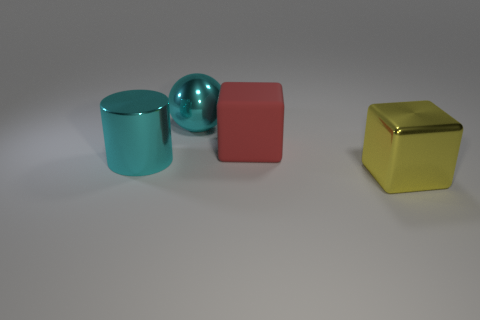How many yellow objects are big balls or metallic things?
Your response must be concise. 1. What number of cubes have the same size as the cyan ball?
Your answer should be compact. 2. What is the shape of the shiny object that is the same color as the large metal sphere?
Your answer should be compact. Cylinder. What number of things are either shiny cylinders or metallic objects that are on the right side of the big cylinder?
Ensure brevity in your answer.  3. There is a block left of the large yellow cube; is it the same size as the shiny thing to the left of the large cyan metallic sphere?
Ensure brevity in your answer.  Yes. What number of large cyan shiny things are the same shape as the yellow object?
Your answer should be very brief. 0. There is a large cyan thing that is made of the same material as the cylinder; what shape is it?
Provide a succinct answer. Sphere. What is the material of the cyan object that is behind the block behind the big block that is in front of the shiny cylinder?
Your response must be concise. Metal. Is the size of the shiny ball the same as the block that is to the left of the yellow shiny thing?
Your answer should be compact. Yes. What material is the other thing that is the same shape as the large yellow thing?
Your answer should be very brief. Rubber. 